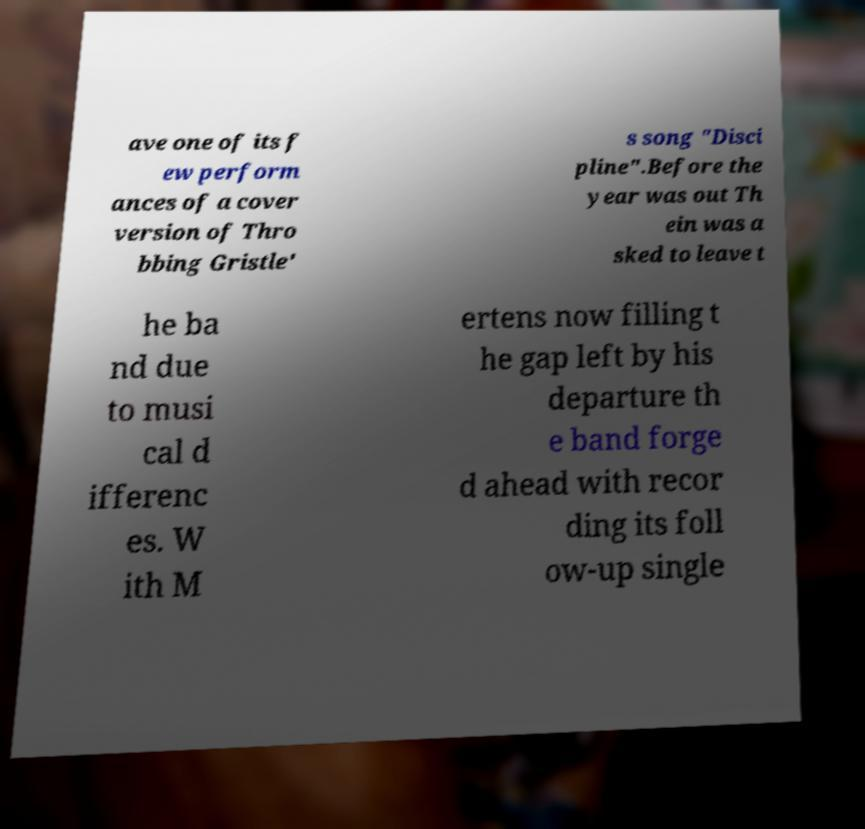There's text embedded in this image that I need extracted. Can you transcribe it verbatim? ave one of its f ew perform ances of a cover version of Thro bbing Gristle' s song "Disci pline".Before the year was out Th ein was a sked to leave t he ba nd due to musi cal d ifferenc es. W ith M ertens now filling t he gap left by his departure th e band forge d ahead with recor ding its foll ow-up single 